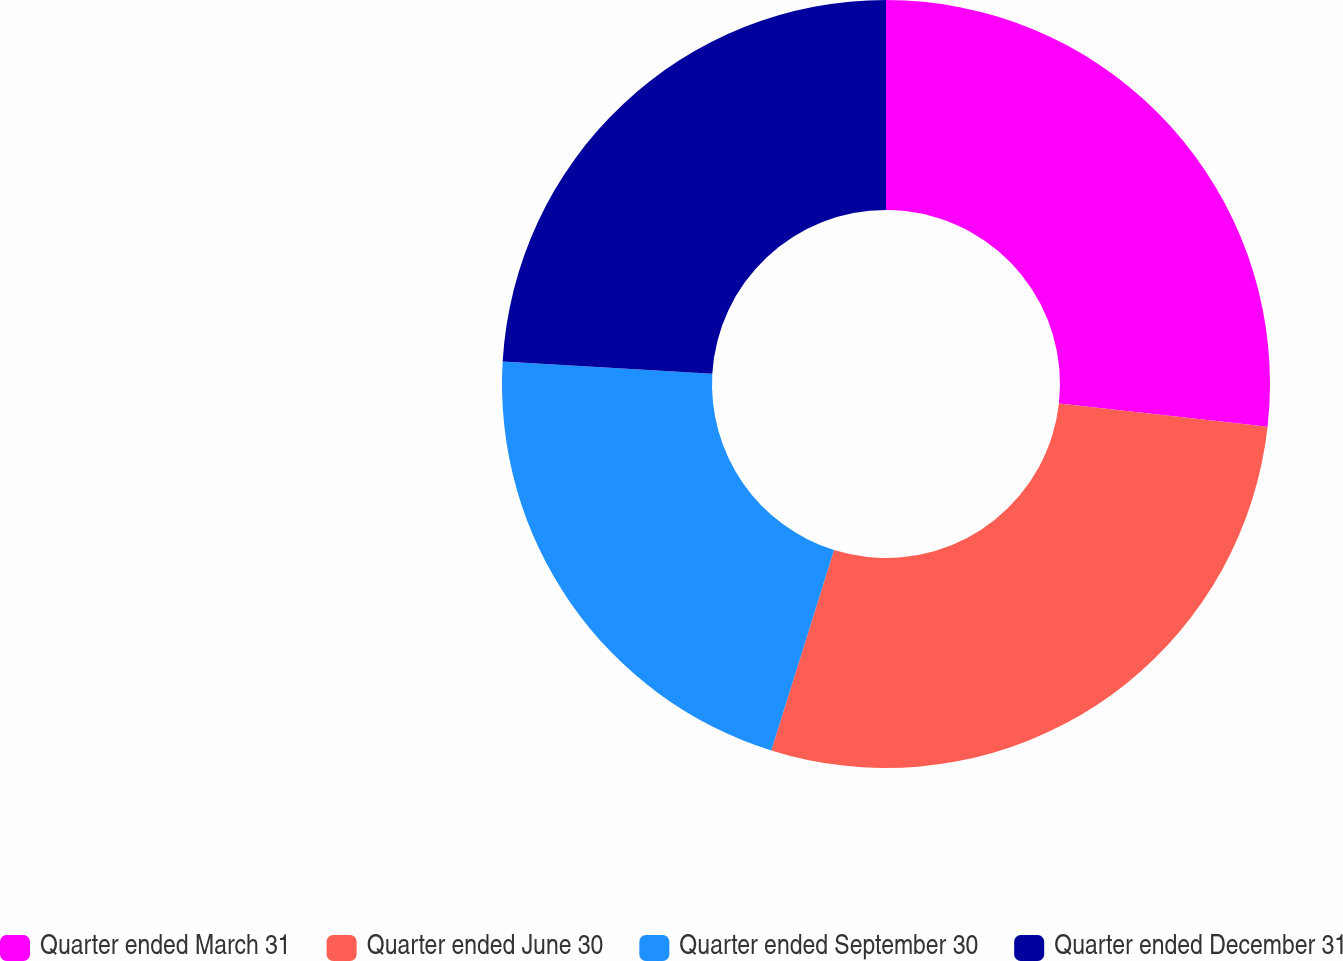<chart> <loc_0><loc_0><loc_500><loc_500><pie_chart><fcel>Quarter ended March 31<fcel>Quarter ended June 30<fcel>Quarter ended September 30<fcel>Quarter ended December 31<nl><fcel>26.78%<fcel>28.05%<fcel>21.1%<fcel>24.07%<nl></chart> 